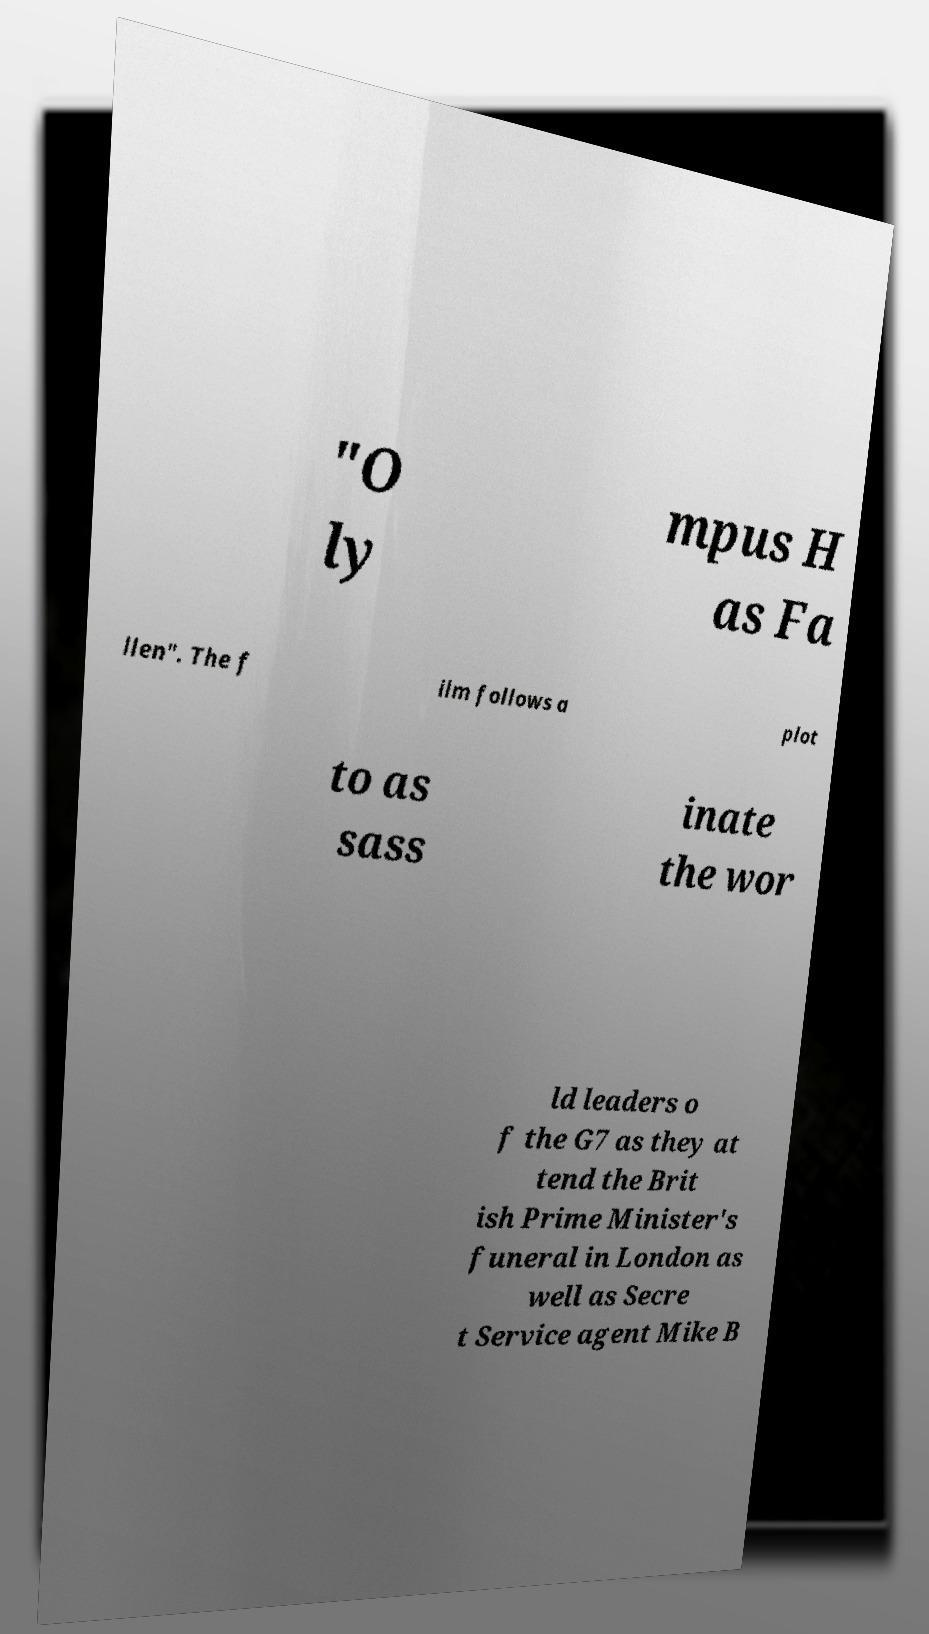There's text embedded in this image that I need extracted. Can you transcribe it verbatim? "O ly mpus H as Fa llen". The f ilm follows a plot to as sass inate the wor ld leaders o f the G7 as they at tend the Brit ish Prime Minister's funeral in London as well as Secre t Service agent Mike B 